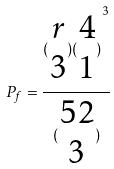<formula> <loc_0><loc_0><loc_500><loc_500>P _ { f } = \frac { ( \begin{matrix} r \\ 3 \end{matrix} ) { ( \begin{matrix} 4 \\ 1 \end{matrix} ) } ^ { 3 } } { ( \begin{matrix} 5 2 \\ 3 \end{matrix} ) }</formula> 